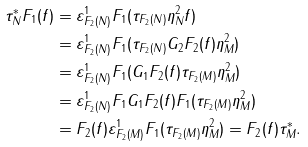Convert formula to latex. <formula><loc_0><loc_0><loc_500><loc_500>\tau ^ { * } _ { N } F _ { 1 } ( f ) & = \varepsilon ^ { 1 } _ { F _ { 2 } ( N ) } F _ { 1 } ( \tau _ { F _ { 2 } ( N ) } \eta ^ { 2 } _ { N } f ) \\ & = \varepsilon ^ { 1 } _ { F _ { 2 } ( N ) } F _ { 1 } ( \tau _ { F _ { 2 } ( N ) } G _ { 2 } F _ { 2 } ( f ) \eta ^ { 2 } _ { M } ) \\ & = \varepsilon ^ { 1 } _ { F _ { 2 } ( N ) } F _ { 1 } ( G _ { 1 } F _ { 2 } ( f ) \tau _ { F _ { 2 } ( M ) } \eta ^ { 2 } _ { M } ) \\ & = \varepsilon ^ { 1 } _ { F _ { 2 } ( N ) } F _ { 1 } G _ { 1 } F _ { 2 } ( f ) F _ { 1 } ( \tau _ { F _ { 2 } ( M ) } \eta ^ { 2 } _ { M } ) \\ & = F _ { 2 } ( f ) \varepsilon ^ { 1 } _ { F _ { 2 } ( M ) } F _ { 1 } ( \tau _ { F _ { 2 } ( M ) } \eta ^ { 2 } _ { M } ) = F _ { 2 } ( f ) \tau ^ { * } _ { M } .</formula> 